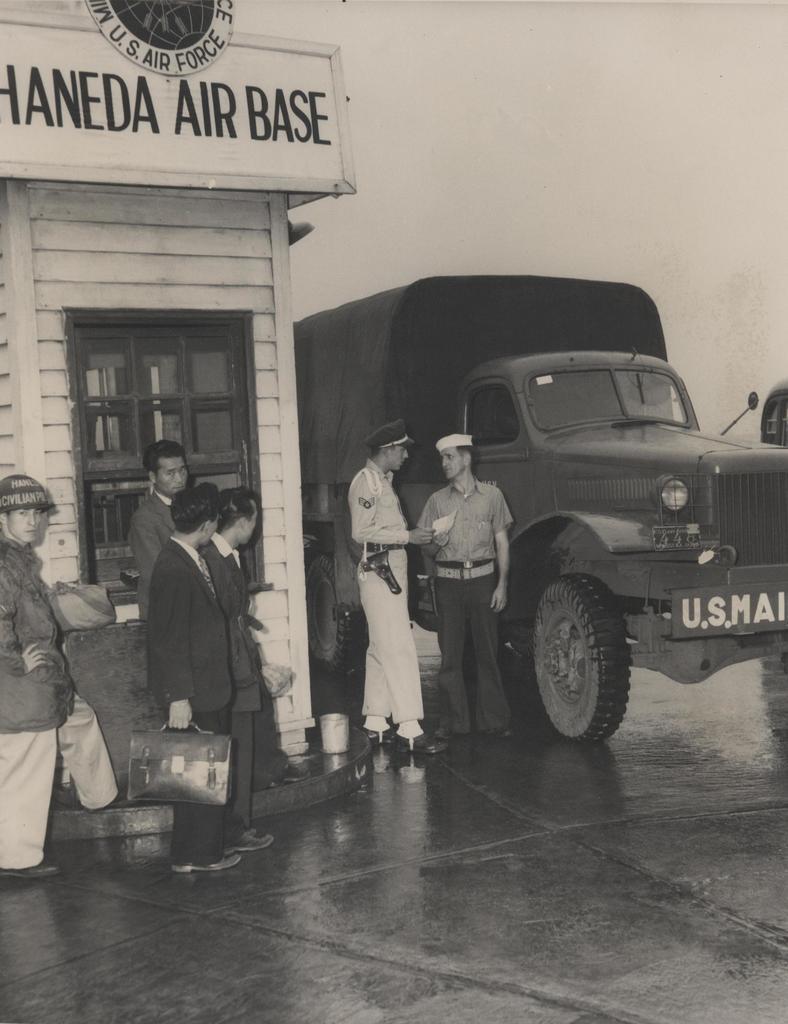Describe this image in one or two sentences. This is a black and white image. There are a few people. We can see the ground and a vehicle. We can see the wall with a window. We can see the board with some image and text. We can see the sky. 